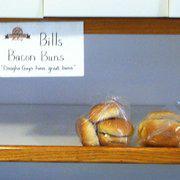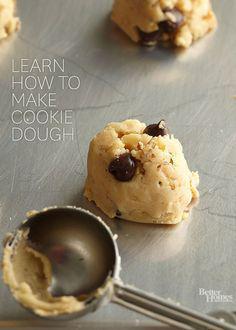The first image is the image on the left, the second image is the image on the right. Evaluate the accuracy of this statement regarding the images: "A metal utinsil is near the baking ingredients in the image on the right.". Is it true? Answer yes or no. Yes. The first image is the image on the left, the second image is the image on the right. Assess this claim about the two images: "a piece of bread that is cut in half is showing all the layers and bubbles inside". Correct or not? Answer yes or no. No. 